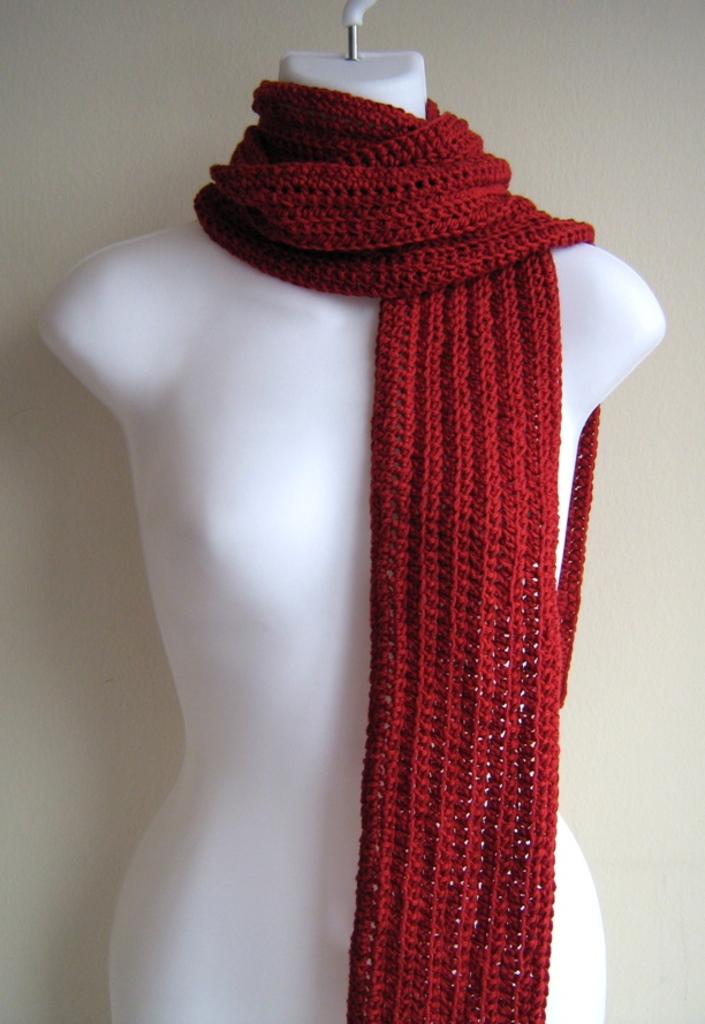What is the main subject in the image? There is a mannequin in the image. What is the mannequin wearing? The mannequin is wearing a scarf. Is the mannequin's aunt planning a vacation in the image? There is no information about the mannequin's aunt or any vacation plans in the image. 